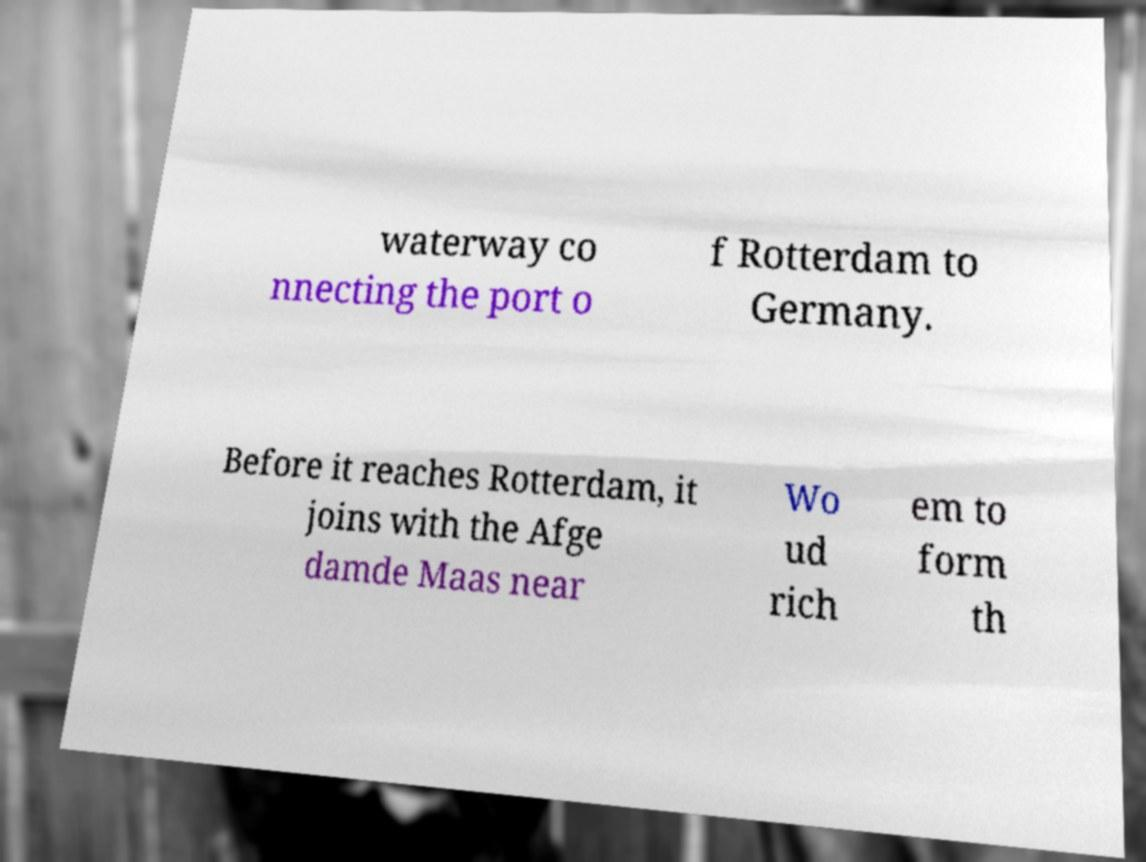Could you extract and type out the text from this image? waterway co nnecting the port o f Rotterdam to Germany. Before it reaches Rotterdam, it joins with the Afge damde Maas near Wo ud rich em to form th 